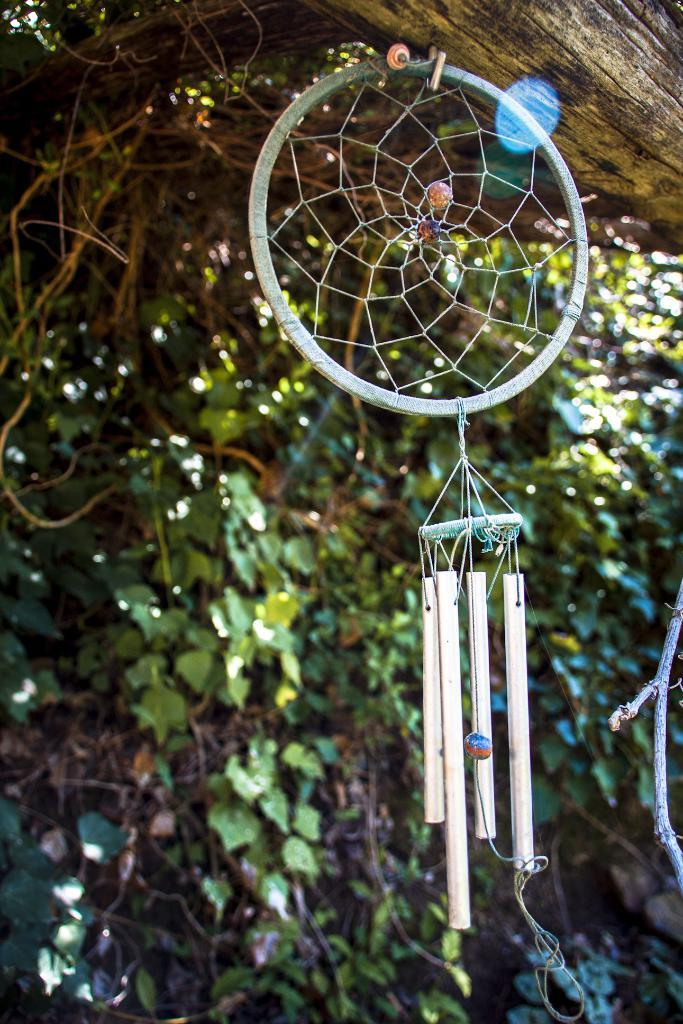What type of plant can be seen in the image? There is a tree in the image. What object is present in the image that could be used for catching or holding? There is a net in the image. What type of police dog can be seen interacting with the tree in the image? There is no police dog present in the image; it only features a tree and a net. What type of crack is visible on the tree in the image? There is no crack visible on the tree in the image. 